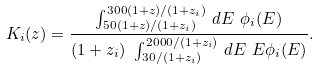Convert formula to latex. <formula><loc_0><loc_0><loc_500><loc_500>K _ { i } ( z ) = \frac { \int ^ { 3 0 0 ( 1 + z ) / ( 1 + z _ { i } ) } _ { 5 0 ( 1 + z ) / ( 1 + z _ { i } ) } \, d E \ \phi _ { i } ( E ) } { ( 1 + z _ { i } ) \ \int ^ { 2 0 0 0 / ( 1 + z _ { i } ) } _ { 3 0 / ( 1 + z _ { i } ) } \, d E \ E \phi _ { i } ( E ) } .</formula> 